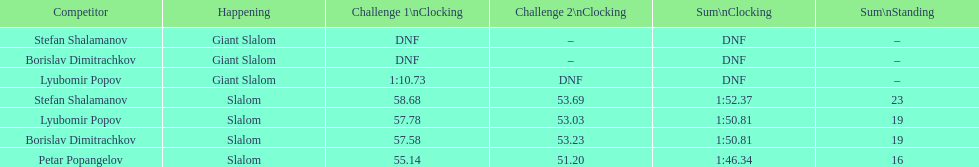Who was the other athlete who tied in rank with lyubomir popov? Borislav Dimitrachkov. 